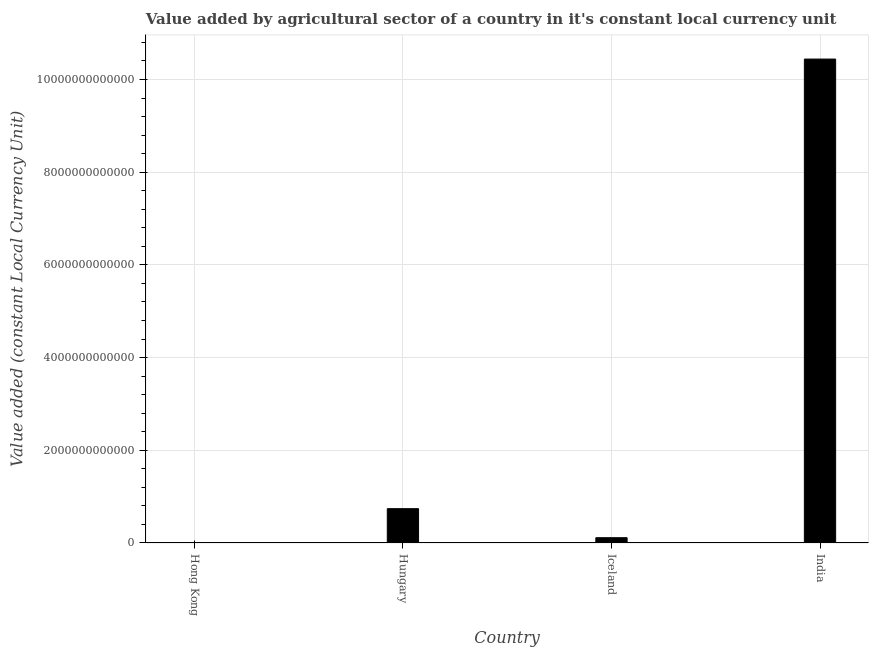Does the graph contain any zero values?
Keep it short and to the point. No. What is the title of the graph?
Ensure brevity in your answer.  Value added by agricultural sector of a country in it's constant local currency unit. What is the label or title of the X-axis?
Your answer should be very brief. Country. What is the label or title of the Y-axis?
Provide a succinct answer. Value added (constant Local Currency Unit). What is the value added by agriculture sector in Hungary?
Your response must be concise. 7.41e+11. Across all countries, what is the maximum value added by agriculture sector?
Offer a terse response. 1.04e+13. Across all countries, what is the minimum value added by agriculture sector?
Your answer should be compact. 1.70e+09. In which country was the value added by agriculture sector maximum?
Give a very brief answer. India. In which country was the value added by agriculture sector minimum?
Provide a succinct answer. Hong Kong. What is the sum of the value added by agriculture sector?
Provide a short and direct response. 1.13e+13. What is the difference between the value added by agriculture sector in Hong Kong and Iceland?
Provide a succinct answer. -1.12e+11. What is the average value added by agriculture sector per country?
Your response must be concise. 2.82e+12. What is the median value added by agriculture sector?
Your response must be concise. 4.27e+11. In how many countries, is the value added by agriculture sector greater than 7200000000000 LCU?
Offer a terse response. 1. What is the ratio of the value added by agriculture sector in Hungary to that in India?
Provide a succinct answer. 0.07. Is the value added by agriculture sector in Hong Kong less than that in Hungary?
Your response must be concise. Yes. Is the difference between the value added by agriculture sector in Hungary and India greater than the difference between any two countries?
Provide a short and direct response. No. What is the difference between the highest and the second highest value added by agriculture sector?
Provide a short and direct response. 9.70e+12. Is the sum of the value added by agriculture sector in Hong Kong and Hungary greater than the maximum value added by agriculture sector across all countries?
Offer a terse response. No. What is the difference between the highest and the lowest value added by agriculture sector?
Ensure brevity in your answer.  1.04e+13. Are all the bars in the graph horizontal?
Keep it short and to the point. No. What is the difference between two consecutive major ticks on the Y-axis?
Provide a short and direct response. 2.00e+12. Are the values on the major ticks of Y-axis written in scientific E-notation?
Your answer should be compact. No. What is the Value added (constant Local Currency Unit) in Hong Kong?
Provide a short and direct response. 1.70e+09. What is the Value added (constant Local Currency Unit) of Hungary?
Provide a short and direct response. 7.41e+11. What is the Value added (constant Local Currency Unit) in Iceland?
Make the answer very short. 1.14e+11. What is the Value added (constant Local Currency Unit) in India?
Provide a succinct answer. 1.04e+13. What is the difference between the Value added (constant Local Currency Unit) in Hong Kong and Hungary?
Offer a very short reply. -7.39e+11. What is the difference between the Value added (constant Local Currency Unit) in Hong Kong and Iceland?
Ensure brevity in your answer.  -1.12e+11. What is the difference between the Value added (constant Local Currency Unit) in Hong Kong and India?
Offer a terse response. -1.04e+13. What is the difference between the Value added (constant Local Currency Unit) in Hungary and Iceland?
Your response must be concise. 6.27e+11. What is the difference between the Value added (constant Local Currency Unit) in Hungary and India?
Offer a very short reply. -9.70e+12. What is the difference between the Value added (constant Local Currency Unit) in Iceland and India?
Offer a terse response. -1.03e+13. What is the ratio of the Value added (constant Local Currency Unit) in Hong Kong to that in Hungary?
Make the answer very short. 0. What is the ratio of the Value added (constant Local Currency Unit) in Hong Kong to that in Iceland?
Make the answer very short. 0.01. What is the ratio of the Value added (constant Local Currency Unit) in Hong Kong to that in India?
Give a very brief answer. 0. What is the ratio of the Value added (constant Local Currency Unit) in Hungary to that in India?
Offer a very short reply. 0.07. What is the ratio of the Value added (constant Local Currency Unit) in Iceland to that in India?
Offer a terse response. 0.01. 